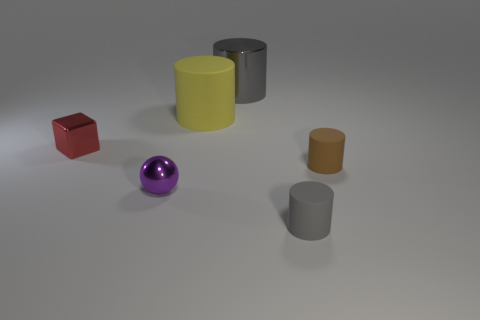Add 1 big cylinders. How many objects exist? 7 Subtract all gray cylinders. How many cylinders are left? 2 Subtract all matte cylinders. How many cylinders are left? 1 Subtract all blocks. How many objects are left? 5 Subtract all small shiny objects. Subtract all big yellow matte cylinders. How many objects are left? 3 Add 5 tiny red metallic blocks. How many tiny red metallic blocks are left? 6 Add 4 tiny blue metallic objects. How many tiny blue metallic objects exist? 4 Subtract 0 gray balls. How many objects are left? 6 Subtract 1 cubes. How many cubes are left? 0 Subtract all green cylinders. Subtract all red spheres. How many cylinders are left? 4 